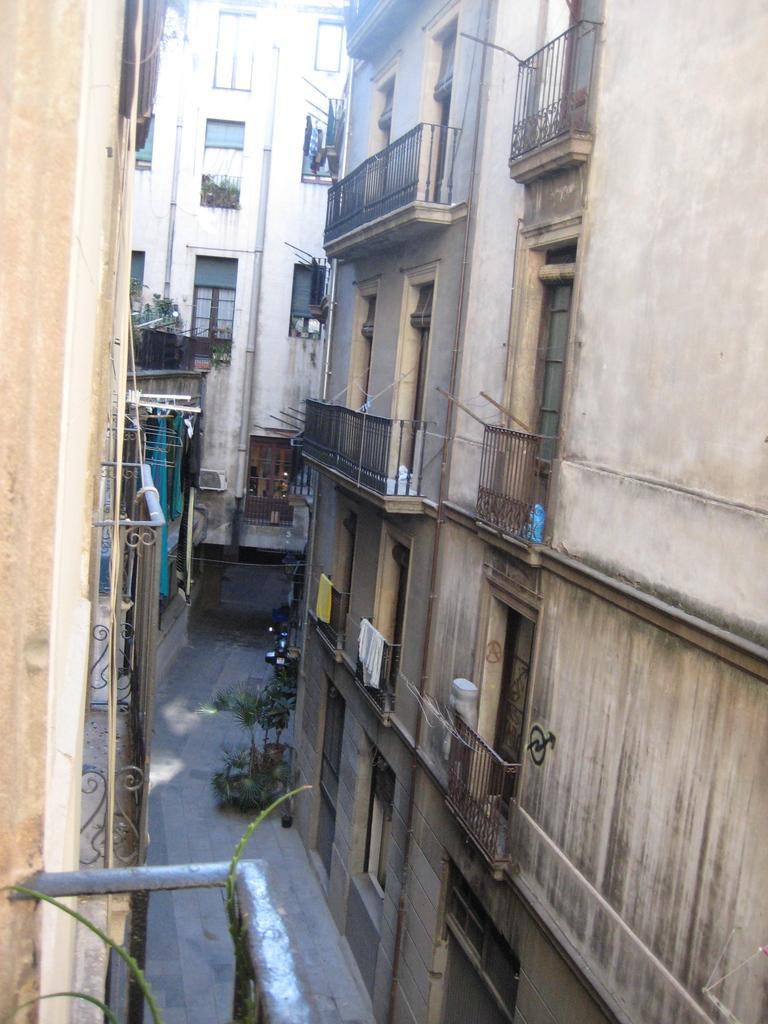Describe this image in one or two sentences. In this image there are buildings and plants. We can see railings and windows. 